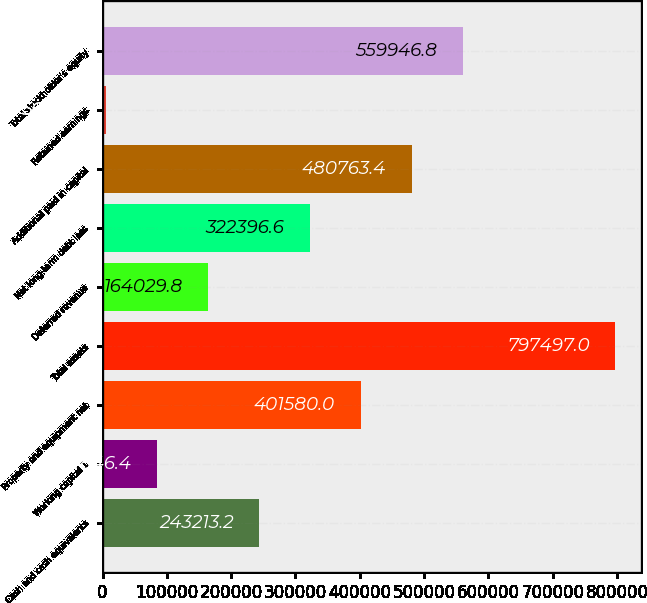<chart> <loc_0><loc_0><loc_500><loc_500><bar_chart><fcel>Cash and cash equivalents<fcel>Working capital 1<fcel>Property and equipment net<fcel>Total assets<fcel>Deferred revenue<fcel>Net long-term debt less<fcel>Additional paid in capital<fcel>Retained earnings<fcel>Total stockholder's equity<nl><fcel>243213<fcel>84846.4<fcel>401580<fcel>797497<fcel>164030<fcel>322397<fcel>480763<fcel>5663<fcel>559947<nl></chart> 